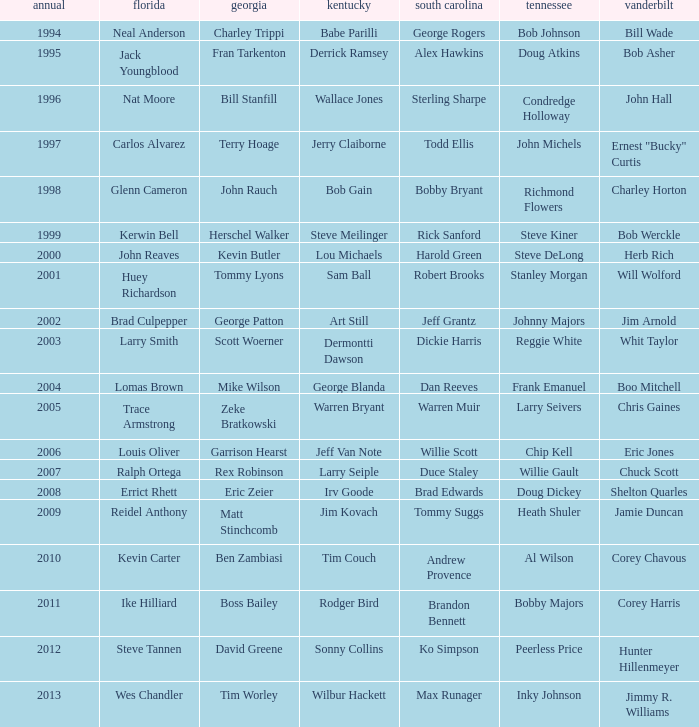What is the total Year of jeff van note ( Kentucky) 2006.0. 